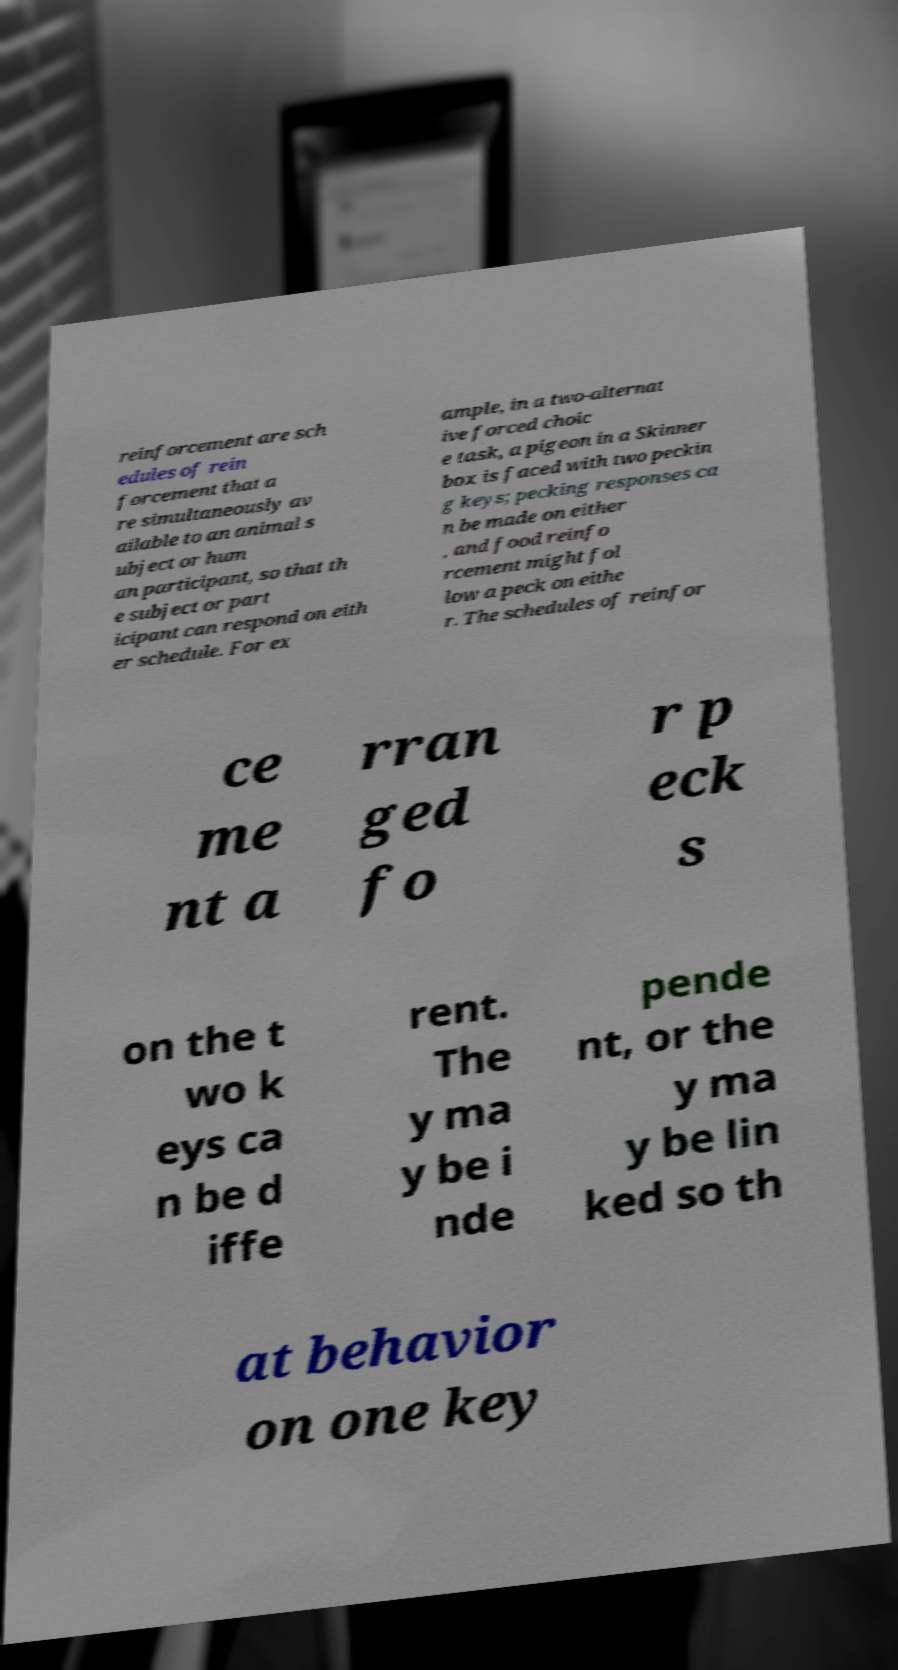Could you assist in decoding the text presented in this image and type it out clearly? reinforcement are sch edules of rein forcement that a re simultaneously av ailable to an animal s ubject or hum an participant, so that th e subject or part icipant can respond on eith er schedule. For ex ample, in a two-alternat ive forced choic e task, a pigeon in a Skinner box is faced with two peckin g keys; pecking responses ca n be made on either , and food reinfo rcement might fol low a peck on eithe r. The schedules of reinfor ce me nt a rran ged fo r p eck s on the t wo k eys ca n be d iffe rent. The y ma y be i nde pende nt, or the y ma y be lin ked so th at behavior on one key 